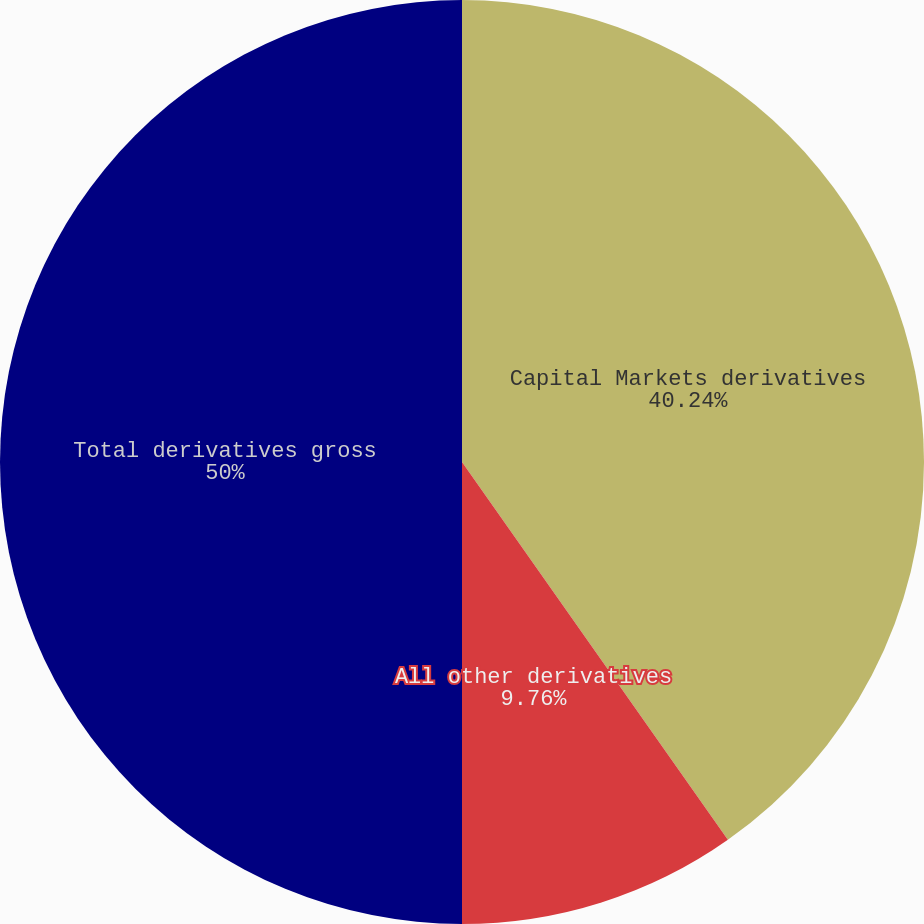Convert chart to OTSL. <chart><loc_0><loc_0><loc_500><loc_500><pie_chart><fcel>Capital Markets derivatives<fcel>All other derivatives<fcel>Total derivatives gross<nl><fcel>40.24%<fcel>9.76%<fcel>50.0%<nl></chart> 